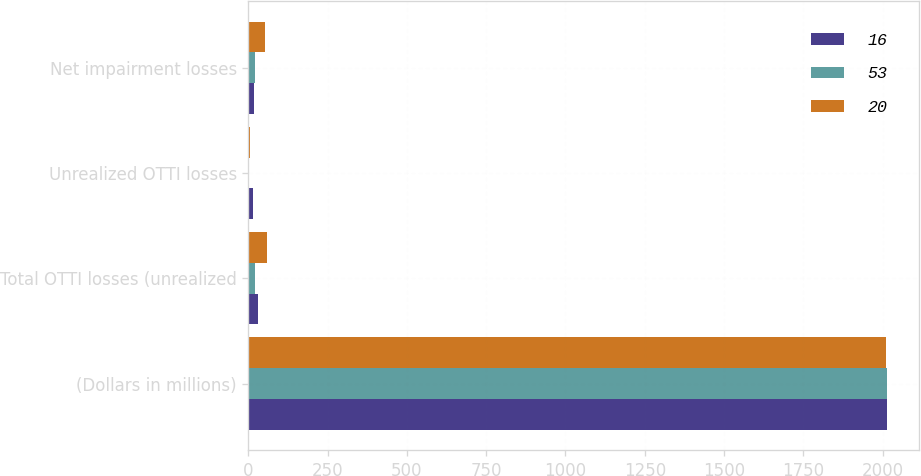Convert chart to OTSL. <chart><loc_0><loc_0><loc_500><loc_500><stacked_bar_chart><ecel><fcel>(Dollars in millions)<fcel>Total OTTI losses (unrealized<fcel>Unrealized OTTI losses<fcel>Net impairment losses<nl><fcel>16<fcel>2014<fcel>30<fcel>14<fcel>16<nl><fcel>53<fcel>2013<fcel>21<fcel>1<fcel>20<nl><fcel>20<fcel>2012<fcel>57<fcel>4<fcel>53<nl></chart> 